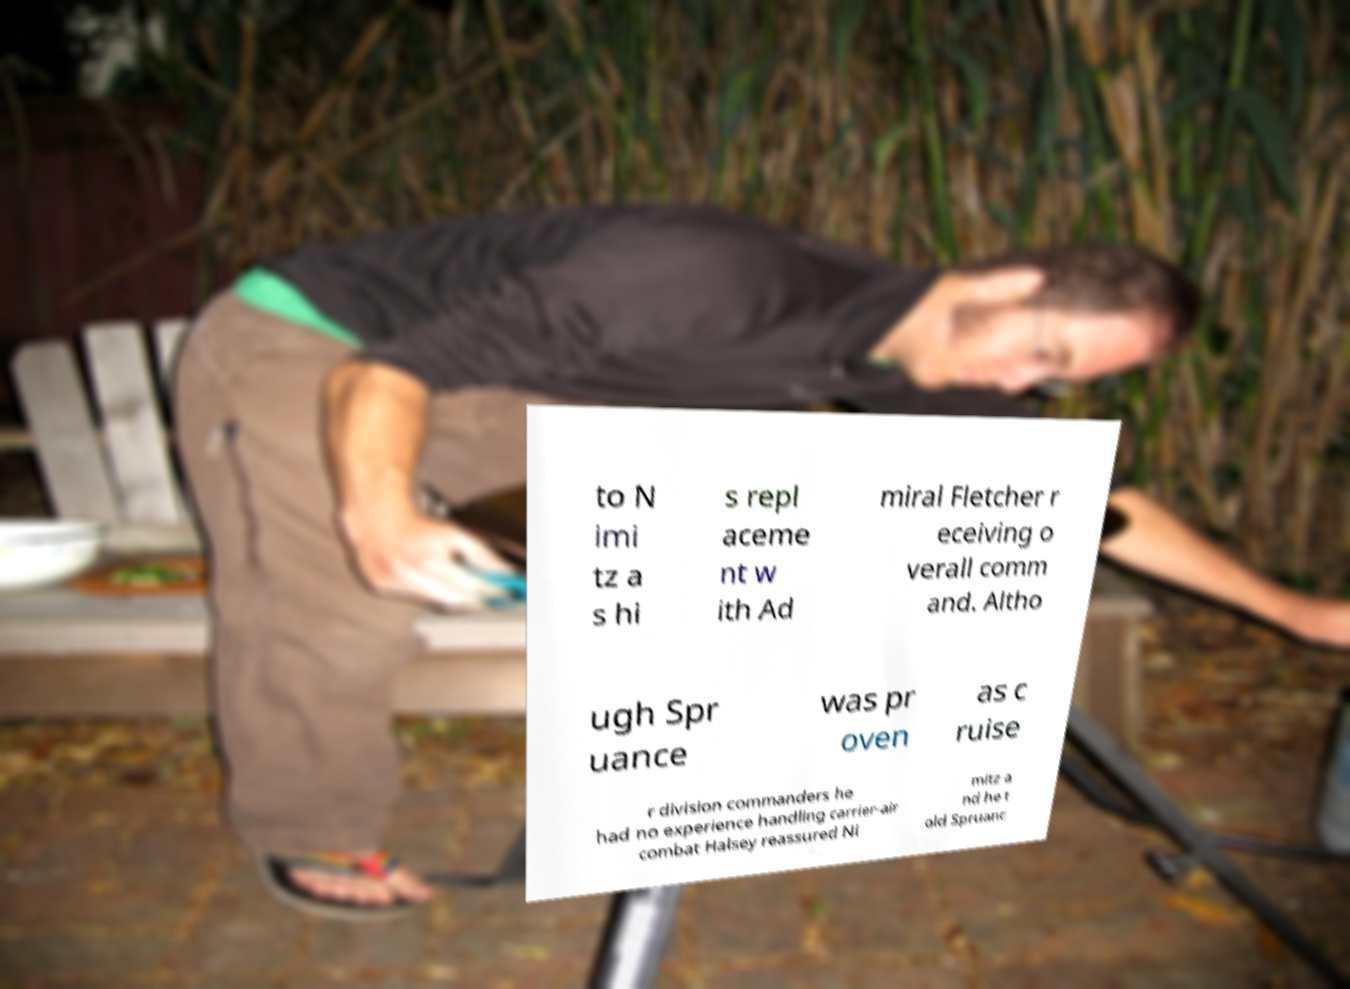There's text embedded in this image that I need extracted. Can you transcribe it verbatim? to N imi tz a s hi s repl aceme nt w ith Ad miral Fletcher r eceiving o verall comm and. Altho ugh Spr uance was pr oven as c ruise r division commanders he had no experience handling carrier-air combat Halsey reassured Ni mitz a nd he t old Spruanc 